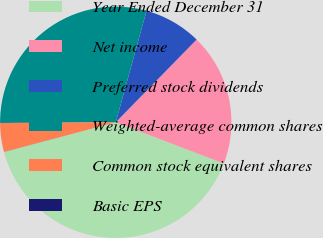<chart> <loc_0><loc_0><loc_500><loc_500><pie_chart><fcel>Year Ended December 31<fcel>Net income<fcel>Preferred stock dividends<fcel>Weighted-average common shares<fcel>Common stock equivalent shares<fcel>Basic EPS<nl><fcel>40.07%<fcel>18.48%<fcel>8.03%<fcel>29.38%<fcel>4.02%<fcel>0.01%<nl></chart> 